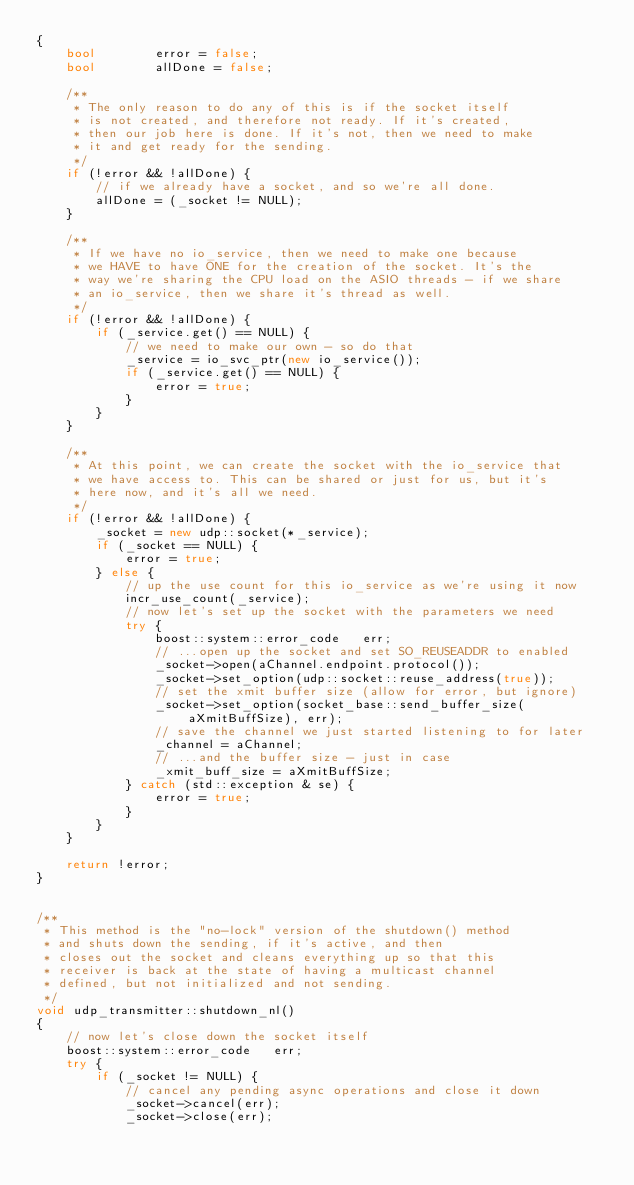<code> <loc_0><loc_0><loc_500><loc_500><_C++_>{
	bool		error = false;
	bool		allDone = false;

	/**
	 * The only reason to do any of this is if the socket itself
	 * is not created, and therefore not ready. If it's created,
	 * then our job here is done. If it's not, then we need to make
	 * it and get ready for the sending.
	 */
	if (!error && !allDone) {
		// if we already have a socket, and so we're all done.
		allDone = (_socket != NULL);
	}

	/**
	 * If we have no io_service, then we need to make one because
	 * we HAVE to have ONE for the creation of the socket. It's the
	 * way we're sharing the CPU load on the ASIO threads - if we share
	 * an io_service, then we share it's thread as well.
	 */
	if (!error && !allDone) {
		if (_service.get() == NULL) {
			// we need to make our own - so do that
			_service = io_svc_ptr(new io_service());
			if (_service.get() == NULL) {
				error = true;
			}
		}
	}

	/**
	 * At this point, we can create the socket with the io_service that
	 * we have access to. This can be shared or just for us, but it's
	 * here now, and it's all we need.
	 */
	if (!error && !allDone) {
		_socket = new udp::socket(*_service);
		if (_socket == NULL) {
			error = true;
		} else {
			// up the use count for this io_service as we're using it now
			incr_use_count(_service);
			// now let's set up the socket with the parameters we need
			try {
				boost::system::error_code	err;
				// ...open up the socket and set SO_REUSEADDR to enabled
				_socket->open(aChannel.endpoint.protocol());
				_socket->set_option(udp::socket::reuse_address(true));
				// set the xmit buffer size (allow for error, but ignore)
				_socket->set_option(socket_base::send_buffer_size(aXmitBuffSize), err);
				// save the channel we just started listening to for later
				_channel = aChannel;
				// ...and the buffer size - just in case
				_xmit_buff_size = aXmitBuffSize;
			} catch (std::exception & se) {
				error = true;
			}
		}
	}

	return !error;
}


/**
 * This method is the "no-lock" version of the shutdown() method
 * and shuts down the sending, if it's active, and then
 * closes out the socket and cleans everything up so that this
 * receiver is back at the state of having a multicast channel
 * defined, but not initialized and not sending.
 */
void udp_transmitter::shutdown_nl()
{
	// now let's close down the socket itself
	boost::system::error_code	err;
	try {
		if (_socket != NULL) {
			// cancel any pending async operations and close it down
			_socket->cancel(err);
			_socket->close(err);</code> 